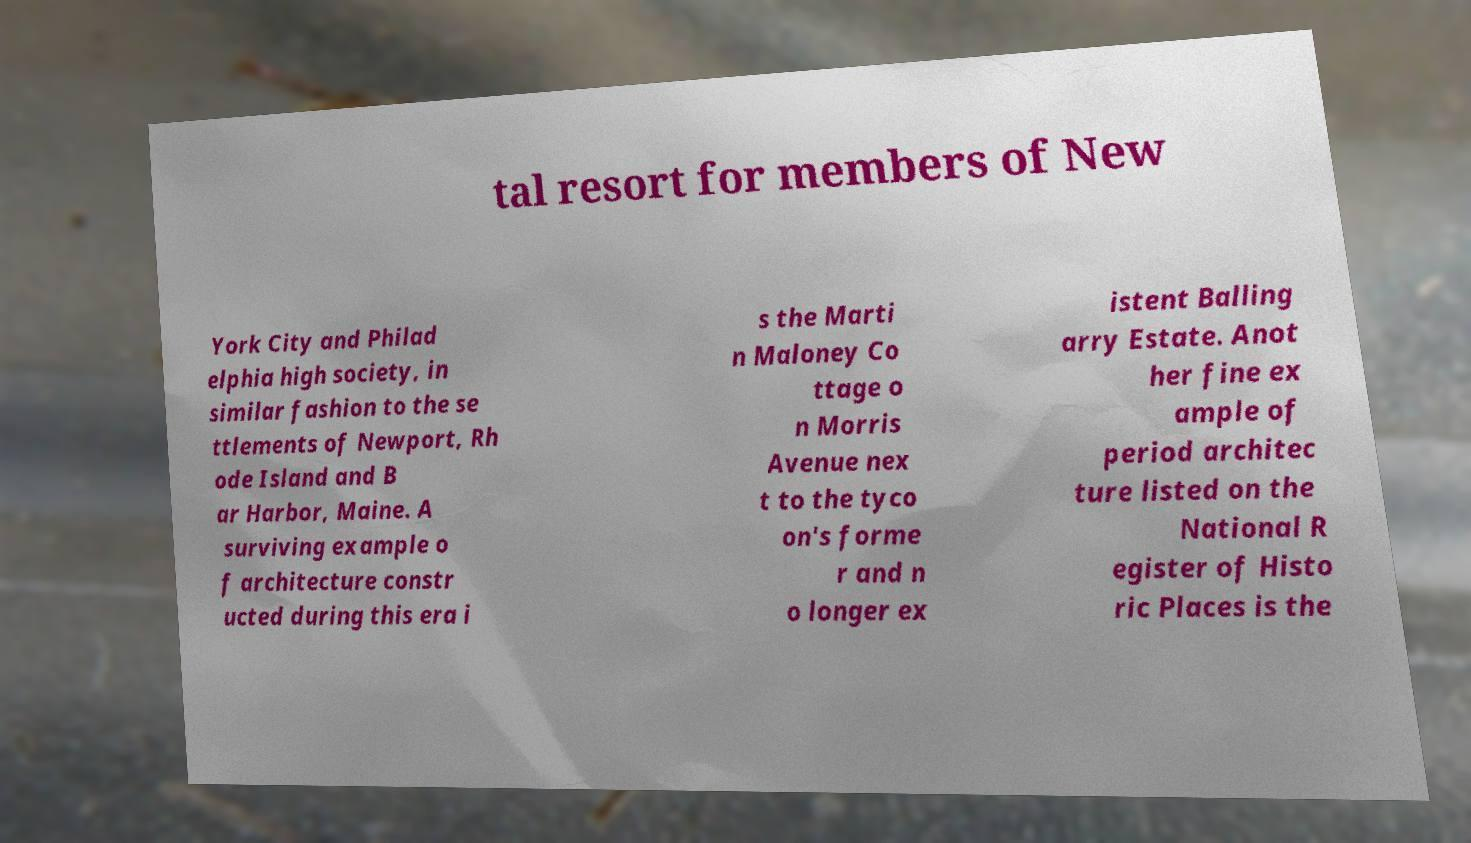I need the written content from this picture converted into text. Can you do that? tal resort for members of New York City and Philad elphia high society, in similar fashion to the se ttlements of Newport, Rh ode Island and B ar Harbor, Maine. A surviving example o f architecture constr ucted during this era i s the Marti n Maloney Co ttage o n Morris Avenue nex t to the tyco on's forme r and n o longer ex istent Balling arry Estate. Anot her fine ex ample of period architec ture listed on the National R egister of Histo ric Places is the 